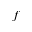Convert formula to latex. <formula><loc_0><loc_0><loc_500><loc_500>f</formula> 